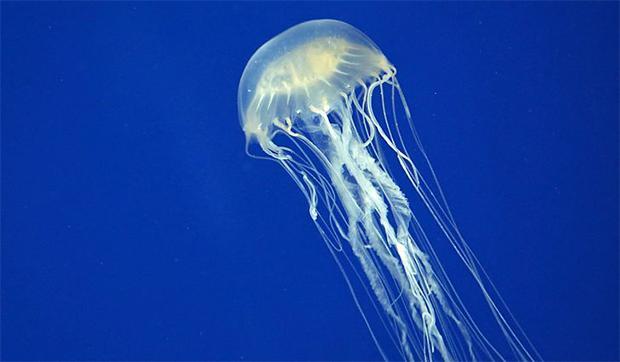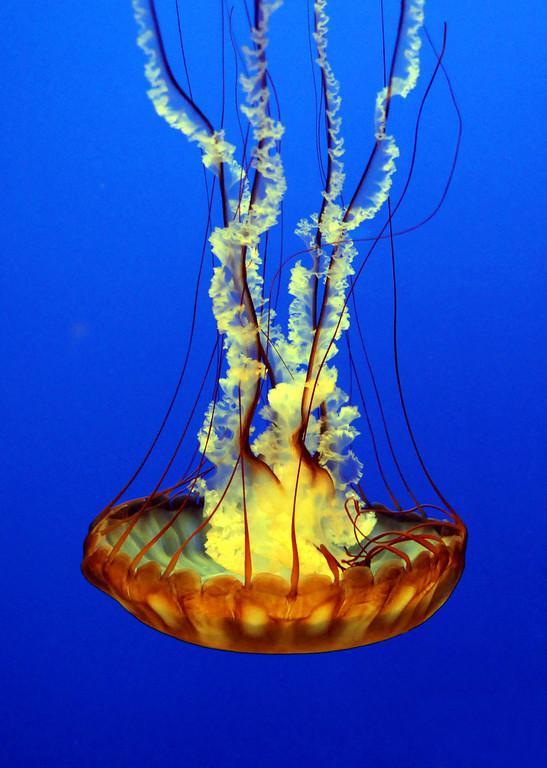The first image is the image on the left, the second image is the image on the right. Considering the images on both sides, is "the left pic has more then three creatures" valid? Answer yes or no. No. The first image is the image on the left, the second image is the image on the right. For the images shown, is this caption "The jellyfish are all swimming up with their tentacles trailing under them." true? Answer yes or no. No. 